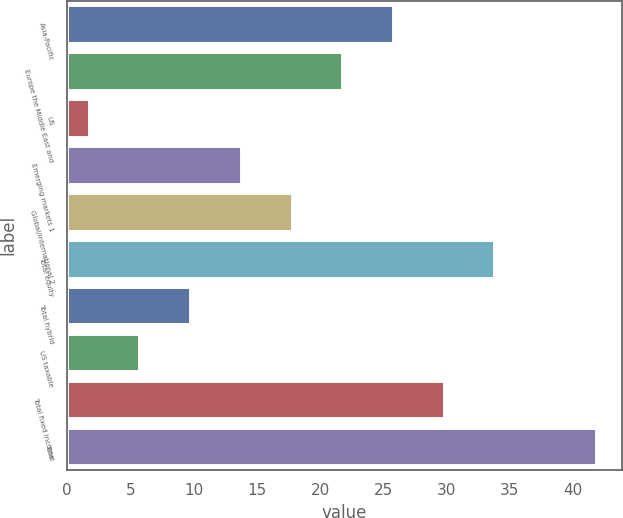<chart> <loc_0><loc_0><loc_500><loc_500><bar_chart><fcel>Asia-Pacific<fcel>Europe the Middle East and<fcel>US<fcel>Emerging markets 1<fcel>Global/international 2<fcel>Total equity<fcel>Total hybrid<fcel>US taxable<fcel>Total fixed income<fcel>Total<nl><fcel>25.76<fcel>21.75<fcel>1.7<fcel>13.73<fcel>17.74<fcel>33.78<fcel>9.72<fcel>5.71<fcel>29.77<fcel>41.8<nl></chart> 